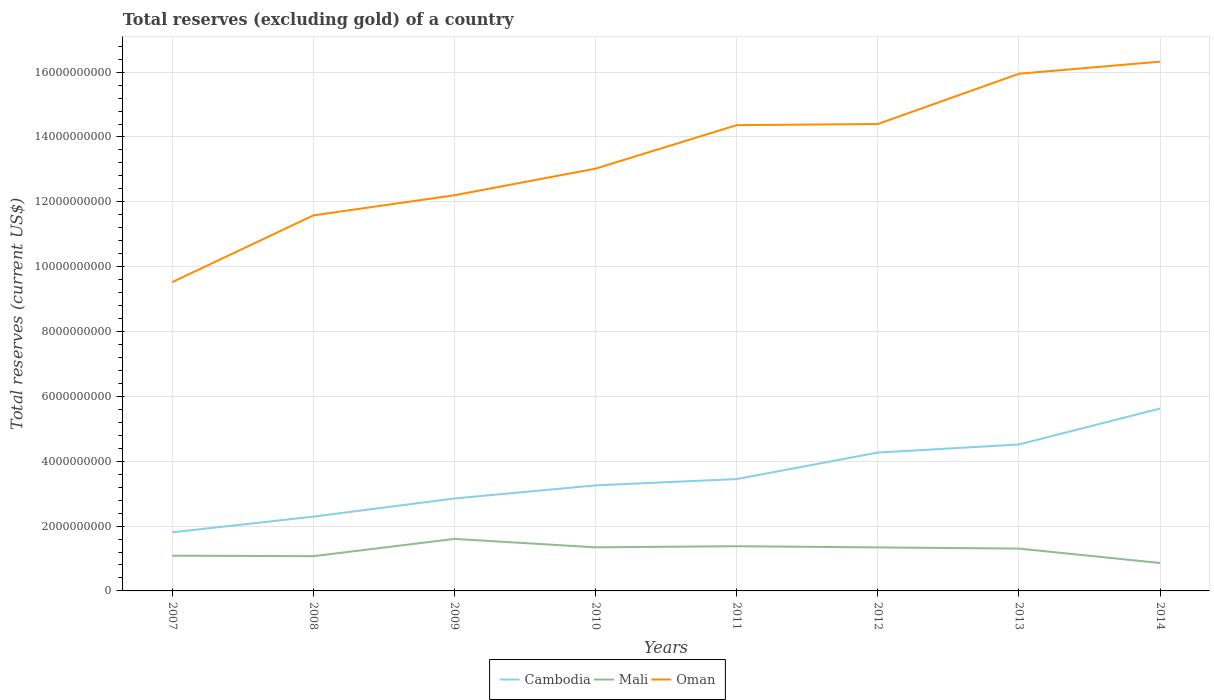Does the line corresponding to Oman intersect with the line corresponding to Cambodia?
Make the answer very short. No. Across all years, what is the maximum total reserves (excluding gold) in Cambodia?
Keep it short and to the point. 1.81e+09. What is the total total reserves (excluding gold) in Mali in the graph?
Give a very brief answer. 7.44e+08. What is the difference between the highest and the second highest total reserves (excluding gold) in Mali?
Your answer should be very brief. 7.44e+08. Is the total reserves (excluding gold) in Mali strictly greater than the total reserves (excluding gold) in Oman over the years?
Make the answer very short. Yes. How many lines are there?
Provide a succinct answer. 3. Does the graph contain grids?
Your answer should be very brief. Yes. Where does the legend appear in the graph?
Provide a succinct answer. Bottom center. How many legend labels are there?
Make the answer very short. 3. What is the title of the graph?
Keep it short and to the point. Total reserves (excluding gold) of a country. What is the label or title of the Y-axis?
Your answer should be very brief. Total reserves (current US$). What is the Total reserves (current US$) of Cambodia in 2007?
Offer a very short reply. 1.81e+09. What is the Total reserves (current US$) of Mali in 2007?
Offer a very short reply. 1.09e+09. What is the Total reserves (current US$) in Oman in 2007?
Give a very brief answer. 9.52e+09. What is the Total reserves (current US$) of Cambodia in 2008?
Provide a succinct answer. 2.29e+09. What is the Total reserves (current US$) of Mali in 2008?
Provide a succinct answer. 1.07e+09. What is the Total reserves (current US$) in Oman in 2008?
Keep it short and to the point. 1.16e+1. What is the Total reserves (current US$) in Cambodia in 2009?
Provide a succinct answer. 2.85e+09. What is the Total reserves (current US$) of Mali in 2009?
Provide a succinct answer. 1.60e+09. What is the Total reserves (current US$) of Oman in 2009?
Make the answer very short. 1.22e+1. What is the Total reserves (current US$) of Cambodia in 2010?
Ensure brevity in your answer.  3.26e+09. What is the Total reserves (current US$) of Mali in 2010?
Provide a succinct answer. 1.34e+09. What is the Total reserves (current US$) of Oman in 2010?
Keep it short and to the point. 1.30e+1. What is the Total reserves (current US$) of Cambodia in 2011?
Your answer should be very brief. 3.45e+09. What is the Total reserves (current US$) of Mali in 2011?
Offer a very short reply. 1.38e+09. What is the Total reserves (current US$) in Oman in 2011?
Provide a succinct answer. 1.44e+1. What is the Total reserves (current US$) in Cambodia in 2012?
Your response must be concise. 4.27e+09. What is the Total reserves (current US$) of Mali in 2012?
Provide a short and direct response. 1.34e+09. What is the Total reserves (current US$) of Oman in 2012?
Offer a terse response. 1.44e+1. What is the Total reserves (current US$) of Cambodia in 2013?
Provide a short and direct response. 4.52e+09. What is the Total reserves (current US$) in Mali in 2013?
Provide a short and direct response. 1.31e+09. What is the Total reserves (current US$) of Oman in 2013?
Offer a very short reply. 1.60e+1. What is the Total reserves (current US$) in Cambodia in 2014?
Provide a short and direct response. 5.63e+09. What is the Total reserves (current US$) of Mali in 2014?
Offer a terse response. 8.61e+08. What is the Total reserves (current US$) of Oman in 2014?
Provide a succinct answer. 1.63e+1. Across all years, what is the maximum Total reserves (current US$) in Cambodia?
Provide a succinct answer. 5.63e+09. Across all years, what is the maximum Total reserves (current US$) in Mali?
Your answer should be very brief. 1.60e+09. Across all years, what is the maximum Total reserves (current US$) in Oman?
Your response must be concise. 1.63e+1. Across all years, what is the minimum Total reserves (current US$) in Cambodia?
Offer a terse response. 1.81e+09. Across all years, what is the minimum Total reserves (current US$) of Mali?
Your response must be concise. 8.61e+08. Across all years, what is the minimum Total reserves (current US$) in Oman?
Make the answer very short. 9.52e+09. What is the total Total reserves (current US$) of Cambodia in the graph?
Keep it short and to the point. 2.81e+1. What is the total Total reserves (current US$) in Mali in the graph?
Your response must be concise. 9.99e+09. What is the total Total reserves (current US$) of Oman in the graph?
Offer a terse response. 1.07e+11. What is the difference between the Total reserves (current US$) of Cambodia in 2007 and that in 2008?
Provide a short and direct response. -4.85e+08. What is the difference between the Total reserves (current US$) in Mali in 2007 and that in 2008?
Offer a very short reply. 1.56e+07. What is the difference between the Total reserves (current US$) of Oman in 2007 and that in 2008?
Make the answer very short. -2.06e+09. What is the difference between the Total reserves (current US$) of Cambodia in 2007 and that in 2009?
Provide a succinct answer. -1.04e+09. What is the difference between the Total reserves (current US$) in Mali in 2007 and that in 2009?
Make the answer very short. -5.17e+08. What is the difference between the Total reserves (current US$) of Oman in 2007 and that in 2009?
Your answer should be very brief. -2.68e+09. What is the difference between the Total reserves (current US$) in Cambodia in 2007 and that in 2010?
Ensure brevity in your answer.  -1.45e+09. What is the difference between the Total reserves (current US$) in Mali in 2007 and that in 2010?
Offer a very short reply. -2.57e+08. What is the difference between the Total reserves (current US$) of Oman in 2007 and that in 2010?
Make the answer very short. -3.50e+09. What is the difference between the Total reserves (current US$) in Cambodia in 2007 and that in 2011?
Keep it short and to the point. -1.64e+09. What is the difference between the Total reserves (current US$) of Mali in 2007 and that in 2011?
Ensure brevity in your answer.  -2.91e+08. What is the difference between the Total reserves (current US$) of Oman in 2007 and that in 2011?
Your answer should be compact. -4.84e+09. What is the difference between the Total reserves (current US$) in Cambodia in 2007 and that in 2012?
Make the answer very short. -2.46e+09. What is the difference between the Total reserves (current US$) of Mali in 2007 and that in 2012?
Offer a terse response. -2.54e+08. What is the difference between the Total reserves (current US$) of Oman in 2007 and that in 2012?
Your answer should be compact. -4.88e+09. What is the difference between the Total reserves (current US$) of Cambodia in 2007 and that in 2013?
Provide a succinct answer. -2.71e+09. What is the difference between the Total reserves (current US$) in Mali in 2007 and that in 2013?
Offer a very short reply. -2.19e+08. What is the difference between the Total reserves (current US$) of Oman in 2007 and that in 2013?
Your answer should be compact. -6.43e+09. What is the difference between the Total reserves (current US$) of Cambodia in 2007 and that in 2014?
Provide a short and direct response. -3.82e+09. What is the difference between the Total reserves (current US$) in Mali in 2007 and that in 2014?
Ensure brevity in your answer.  2.26e+08. What is the difference between the Total reserves (current US$) of Oman in 2007 and that in 2014?
Make the answer very short. -6.80e+09. What is the difference between the Total reserves (current US$) in Cambodia in 2008 and that in 2009?
Provide a short and direct response. -5.60e+08. What is the difference between the Total reserves (current US$) in Mali in 2008 and that in 2009?
Make the answer very short. -5.33e+08. What is the difference between the Total reserves (current US$) of Oman in 2008 and that in 2009?
Your response must be concise. -6.21e+08. What is the difference between the Total reserves (current US$) of Cambodia in 2008 and that in 2010?
Make the answer very short. -9.64e+08. What is the difference between the Total reserves (current US$) in Mali in 2008 and that in 2010?
Your answer should be compact. -2.73e+08. What is the difference between the Total reserves (current US$) of Oman in 2008 and that in 2010?
Your answer should be compact. -1.44e+09. What is the difference between the Total reserves (current US$) in Cambodia in 2008 and that in 2011?
Your response must be concise. -1.16e+09. What is the difference between the Total reserves (current US$) in Mali in 2008 and that in 2011?
Make the answer very short. -3.07e+08. What is the difference between the Total reserves (current US$) of Oman in 2008 and that in 2011?
Offer a very short reply. -2.78e+09. What is the difference between the Total reserves (current US$) in Cambodia in 2008 and that in 2012?
Provide a short and direct response. -1.98e+09. What is the difference between the Total reserves (current US$) in Mali in 2008 and that in 2012?
Offer a very short reply. -2.70e+08. What is the difference between the Total reserves (current US$) in Oman in 2008 and that in 2012?
Your answer should be very brief. -2.82e+09. What is the difference between the Total reserves (current US$) in Cambodia in 2008 and that in 2013?
Offer a very short reply. -2.22e+09. What is the difference between the Total reserves (current US$) of Mali in 2008 and that in 2013?
Ensure brevity in your answer.  -2.34e+08. What is the difference between the Total reserves (current US$) in Oman in 2008 and that in 2013?
Your response must be concise. -4.37e+09. What is the difference between the Total reserves (current US$) in Cambodia in 2008 and that in 2014?
Make the answer very short. -3.33e+09. What is the difference between the Total reserves (current US$) in Mali in 2008 and that in 2014?
Provide a short and direct response. 2.11e+08. What is the difference between the Total reserves (current US$) in Oman in 2008 and that in 2014?
Make the answer very short. -4.74e+09. What is the difference between the Total reserves (current US$) of Cambodia in 2009 and that in 2010?
Offer a very short reply. -4.04e+08. What is the difference between the Total reserves (current US$) in Mali in 2009 and that in 2010?
Offer a terse response. 2.60e+08. What is the difference between the Total reserves (current US$) in Oman in 2009 and that in 2010?
Make the answer very short. -8.21e+08. What is the difference between the Total reserves (current US$) of Cambodia in 2009 and that in 2011?
Make the answer very short. -5.99e+08. What is the difference between the Total reserves (current US$) in Mali in 2009 and that in 2011?
Keep it short and to the point. 2.26e+08. What is the difference between the Total reserves (current US$) in Oman in 2009 and that in 2011?
Provide a short and direct response. -2.16e+09. What is the difference between the Total reserves (current US$) in Cambodia in 2009 and that in 2012?
Ensure brevity in your answer.  -1.42e+09. What is the difference between the Total reserves (current US$) of Mali in 2009 and that in 2012?
Your answer should be very brief. 2.63e+08. What is the difference between the Total reserves (current US$) in Oman in 2009 and that in 2012?
Make the answer very short. -2.20e+09. What is the difference between the Total reserves (current US$) in Cambodia in 2009 and that in 2013?
Offer a very short reply. -1.67e+09. What is the difference between the Total reserves (current US$) of Mali in 2009 and that in 2013?
Provide a succinct answer. 2.99e+08. What is the difference between the Total reserves (current US$) of Oman in 2009 and that in 2013?
Your answer should be compact. -3.75e+09. What is the difference between the Total reserves (current US$) in Cambodia in 2009 and that in 2014?
Provide a succinct answer. -2.77e+09. What is the difference between the Total reserves (current US$) of Mali in 2009 and that in 2014?
Keep it short and to the point. 7.44e+08. What is the difference between the Total reserves (current US$) in Oman in 2009 and that in 2014?
Give a very brief answer. -4.12e+09. What is the difference between the Total reserves (current US$) of Cambodia in 2010 and that in 2011?
Your answer should be compact. -1.95e+08. What is the difference between the Total reserves (current US$) in Mali in 2010 and that in 2011?
Provide a short and direct response. -3.42e+07. What is the difference between the Total reserves (current US$) in Oman in 2010 and that in 2011?
Provide a short and direct response. -1.34e+09. What is the difference between the Total reserves (current US$) of Cambodia in 2010 and that in 2012?
Make the answer very short. -1.01e+09. What is the difference between the Total reserves (current US$) in Mali in 2010 and that in 2012?
Keep it short and to the point. 3.01e+06. What is the difference between the Total reserves (current US$) in Oman in 2010 and that in 2012?
Your answer should be compact. -1.38e+09. What is the difference between the Total reserves (current US$) in Cambodia in 2010 and that in 2013?
Provide a succinct answer. -1.26e+09. What is the difference between the Total reserves (current US$) in Mali in 2010 and that in 2013?
Give a very brief answer. 3.87e+07. What is the difference between the Total reserves (current US$) of Oman in 2010 and that in 2013?
Provide a succinct answer. -2.93e+09. What is the difference between the Total reserves (current US$) in Cambodia in 2010 and that in 2014?
Ensure brevity in your answer.  -2.37e+09. What is the difference between the Total reserves (current US$) of Mali in 2010 and that in 2014?
Provide a succinct answer. 4.84e+08. What is the difference between the Total reserves (current US$) in Oman in 2010 and that in 2014?
Your answer should be very brief. -3.30e+09. What is the difference between the Total reserves (current US$) of Cambodia in 2011 and that in 2012?
Ensure brevity in your answer.  -8.18e+08. What is the difference between the Total reserves (current US$) in Mali in 2011 and that in 2012?
Keep it short and to the point. 3.72e+07. What is the difference between the Total reserves (current US$) of Oman in 2011 and that in 2012?
Ensure brevity in your answer.  -3.48e+07. What is the difference between the Total reserves (current US$) of Cambodia in 2011 and that in 2013?
Ensure brevity in your answer.  -1.07e+09. What is the difference between the Total reserves (current US$) of Mali in 2011 and that in 2013?
Keep it short and to the point. 7.29e+07. What is the difference between the Total reserves (current US$) of Oman in 2011 and that in 2013?
Make the answer very short. -1.59e+09. What is the difference between the Total reserves (current US$) in Cambodia in 2011 and that in 2014?
Offer a very short reply. -2.18e+09. What is the difference between the Total reserves (current US$) in Mali in 2011 and that in 2014?
Give a very brief answer. 5.18e+08. What is the difference between the Total reserves (current US$) in Oman in 2011 and that in 2014?
Ensure brevity in your answer.  -1.96e+09. What is the difference between the Total reserves (current US$) in Cambodia in 2012 and that in 2013?
Ensure brevity in your answer.  -2.49e+08. What is the difference between the Total reserves (current US$) of Mali in 2012 and that in 2013?
Offer a terse response. 3.57e+07. What is the difference between the Total reserves (current US$) in Oman in 2012 and that in 2013?
Offer a terse response. -1.55e+09. What is the difference between the Total reserves (current US$) of Cambodia in 2012 and that in 2014?
Offer a very short reply. -1.36e+09. What is the difference between the Total reserves (current US$) of Mali in 2012 and that in 2014?
Provide a succinct answer. 4.81e+08. What is the difference between the Total reserves (current US$) in Oman in 2012 and that in 2014?
Keep it short and to the point. -1.92e+09. What is the difference between the Total reserves (current US$) of Cambodia in 2013 and that in 2014?
Make the answer very short. -1.11e+09. What is the difference between the Total reserves (current US$) in Mali in 2013 and that in 2014?
Your answer should be compact. 4.45e+08. What is the difference between the Total reserves (current US$) of Oman in 2013 and that in 2014?
Keep it short and to the point. -3.73e+08. What is the difference between the Total reserves (current US$) in Cambodia in 2007 and the Total reserves (current US$) in Mali in 2008?
Your answer should be very brief. 7.35e+08. What is the difference between the Total reserves (current US$) of Cambodia in 2007 and the Total reserves (current US$) of Oman in 2008?
Ensure brevity in your answer.  -9.77e+09. What is the difference between the Total reserves (current US$) in Mali in 2007 and the Total reserves (current US$) in Oman in 2008?
Your answer should be compact. -1.05e+1. What is the difference between the Total reserves (current US$) of Cambodia in 2007 and the Total reserves (current US$) of Mali in 2009?
Provide a short and direct response. 2.02e+08. What is the difference between the Total reserves (current US$) of Cambodia in 2007 and the Total reserves (current US$) of Oman in 2009?
Make the answer very short. -1.04e+1. What is the difference between the Total reserves (current US$) in Mali in 2007 and the Total reserves (current US$) in Oman in 2009?
Offer a terse response. -1.11e+1. What is the difference between the Total reserves (current US$) of Cambodia in 2007 and the Total reserves (current US$) of Mali in 2010?
Make the answer very short. 4.63e+08. What is the difference between the Total reserves (current US$) in Cambodia in 2007 and the Total reserves (current US$) in Oman in 2010?
Your response must be concise. -1.12e+1. What is the difference between the Total reserves (current US$) of Mali in 2007 and the Total reserves (current US$) of Oman in 2010?
Offer a very short reply. -1.19e+1. What is the difference between the Total reserves (current US$) of Cambodia in 2007 and the Total reserves (current US$) of Mali in 2011?
Ensure brevity in your answer.  4.28e+08. What is the difference between the Total reserves (current US$) of Cambodia in 2007 and the Total reserves (current US$) of Oman in 2011?
Ensure brevity in your answer.  -1.26e+1. What is the difference between the Total reserves (current US$) in Mali in 2007 and the Total reserves (current US$) in Oman in 2011?
Offer a very short reply. -1.33e+1. What is the difference between the Total reserves (current US$) of Cambodia in 2007 and the Total reserves (current US$) of Mali in 2012?
Give a very brief answer. 4.66e+08. What is the difference between the Total reserves (current US$) in Cambodia in 2007 and the Total reserves (current US$) in Oman in 2012?
Offer a terse response. -1.26e+1. What is the difference between the Total reserves (current US$) of Mali in 2007 and the Total reserves (current US$) of Oman in 2012?
Your answer should be compact. -1.33e+1. What is the difference between the Total reserves (current US$) in Cambodia in 2007 and the Total reserves (current US$) in Mali in 2013?
Provide a short and direct response. 5.01e+08. What is the difference between the Total reserves (current US$) in Cambodia in 2007 and the Total reserves (current US$) in Oman in 2013?
Give a very brief answer. -1.41e+1. What is the difference between the Total reserves (current US$) of Mali in 2007 and the Total reserves (current US$) of Oman in 2013?
Ensure brevity in your answer.  -1.49e+1. What is the difference between the Total reserves (current US$) in Cambodia in 2007 and the Total reserves (current US$) in Mali in 2014?
Offer a very short reply. 9.46e+08. What is the difference between the Total reserves (current US$) of Cambodia in 2007 and the Total reserves (current US$) of Oman in 2014?
Keep it short and to the point. -1.45e+1. What is the difference between the Total reserves (current US$) in Mali in 2007 and the Total reserves (current US$) in Oman in 2014?
Give a very brief answer. -1.52e+1. What is the difference between the Total reserves (current US$) in Cambodia in 2008 and the Total reserves (current US$) in Mali in 2009?
Give a very brief answer. 6.87e+08. What is the difference between the Total reserves (current US$) of Cambodia in 2008 and the Total reserves (current US$) of Oman in 2009?
Your answer should be compact. -9.91e+09. What is the difference between the Total reserves (current US$) in Mali in 2008 and the Total reserves (current US$) in Oman in 2009?
Ensure brevity in your answer.  -1.11e+1. What is the difference between the Total reserves (current US$) of Cambodia in 2008 and the Total reserves (current US$) of Mali in 2010?
Give a very brief answer. 9.47e+08. What is the difference between the Total reserves (current US$) of Cambodia in 2008 and the Total reserves (current US$) of Oman in 2010?
Give a very brief answer. -1.07e+1. What is the difference between the Total reserves (current US$) of Mali in 2008 and the Total reserves (current US$) of Oman in 2010?
Offer a very short reply. -1.20e+1. What is the difference between the Total reserves (current US$) in Cambodia in 2008 and the Total reserves (current US$) in Mali in 2011?
Offer a very short reply. 9.13e+08. What is the difference between the Total reserves (current US$) of Cambodia in 2008 and the Total reserves (current US$) of Oman in 2011?
Give a very brief answer. -1.21e+1. What is the difference between the Total reserves (current US$) of Mali in 2008 and the Total reserves (current US$) of Oman in 2011?
Offer a very short reply. -1.33e+1. What is the difference between the Total reserves (current US$) in Cambodia in 2008 and the Total reserves (current US$) in Mali in 2012?
Offer a very short reply. 9.50e+08. What is the difference between the Total reserves (current US$) in Cambodia in 2008 and the Total reserves (current US$) in Oman in 2012?
Your answer should be compact. -1.21e+1. What is the difference between the Total reserves (current US$) of Mali in 2008 and the Total reserves (current US$) of Oman in 2012?
Your answer should be very brief. -1.33e+1. What is the difference between the Total reserves (current US$) in Cambodia in 2008 and the Total reserves (current US$) in Mali in 2013?
Offer a terse response. 9.86e+08. What is the difference between the Total reserves (current US$) of Cambodia in 2008 and the Total reserves (current US$) of Oman in 2013?
Ensure brevity in your answer.  -1.37e+1. What is the difference between the Total reserves (current US$) in Mali in 2008 and the Total reserves (current US$) in Oman in 2013?
Your answer should be very brief. -1.49e+1. What is the difference between the Total reserves (current US$) of Cambodia in 2008 and the Total reserves (current US$) of Mali in 2014?
Make the answer very short. 1.43e+09. What is the difference between the Total reserves (current US$) in Cambodia in 2008 and the Total reserves (current US$) in Oman in 2014?
Ensure brevity in your answer.  -1.40e+1. What is the difference between the Total reserves (current US$) of Mali in 2008 and the Total reserves (current US$) of Oman in 2014?
Keep it short and to the point. -1.53e+1. What is the difference between the Total reserves (current US$) of Cambodia in 2009 and the Total reserves (current US$) of Mali in 2010?
Keep it short and to the point. 1.51e+09. What is the difference between the Total reserves (current US$) of Cambodia in 2009 and the Total reserves (current US$) of Oman in 2010?
Provide a short and direct response. -1.02e+1. What is the difference between the Total reserves (current US$) of Mali in 2009 and the Total reserves (current US$) of Oman in 2010?
Your answer should be compact. -1.14e+1. What is the difference between the Total reserves (current US$) of Cambodia in 2009 and the Total reserves (current US$) of Mali in 2011?
Keep it short and to the point. 1.47e+09. What is the difference between the Total reserves (current US$) in Cambodia in 2009 and the Total reserves (current US$) in Oman in 2011?
Provide a succinct answer. -1.15e+1. What is the difference between the Total reserves (current US$) of Mali in 2009 and the Total reserves (current US$) of Oman in 2011?
Ensure brevity in your answer.  -1.28e+1. What is the difference between the Total reserves (current US$) of Cambodia in 2009 and the Total reserves (current US$) of Mali in 2012?
Keep it short and to the point. 1.51e+09. What is the difference between the Total reserves (current US$) in Cambodia in 2009 and the Total reserves (current US$) in Oman in 2012?
Your response must be concise. -1.15e+1. What is the difference between the Total reserves (current US$) in Mali in 2009 and the Total reserves (current US$) in Oman in 2012?
Provide a succinct answer. -1.28e+1. What is the difference between the Total reserves (current US$) in Cambodia in 2009 and the Total reserves (current US$) in Mali in 2013?
Your answer should be very brief. 1.55e+09. What is the difference between the Total reserves (current US$) of Cambodia in 2009 and the Total reserves (current US$) of Oman in 2013?
Ensure brevity in your answer.  -1.31e+1. What is the difference between the Total reserves (current US$) in Mali in 2009 and the Total reserves (current US$) in Oman in 2013?
Provide a short and direct response. -1.43e+1. What is the difference between the Total reserves (current US$) of Cambodia in 2009 and the Total reserves (current US$) of Mali in 2014?
Make the answer very short. 1.99e+09. What is the difference between the Total reserves (current US$) of Cambodia in 2009 and the Total reserves (current US$) of Oman in 2014?
Your answer should be compact. -1.35e+1. What is the difference between the Total reserves (current US$) of Mali in 2009 and the Total reserves (current US$) of Oman in 2014?
Give a very brief answer. -1.47e+1. What is the difference between the Total reserves (current US$) of Cambodia in 2010 and the Total reserves (current US$) of Mali in 2011?
Provide a short and direct response. 1.88e+09. What is the difference between the Total reserves (current US$) in Cambodia in 2010 and the Total reserves (current US$) in Oman in 2011?
Offer a very short reply. -1.11e+1. What is the difference between the Total reserves (current US$) in Mali in 2010 and the Total reserves (current US$) in Oman in 2011?
Give a very brief answer. -1.30e+1. What is the difference between the Total reserves (current US$) in Cambodia in 2010 and the Total reserves (current US$) in Mali in 2012?
Provide a short and direct response. 1.91e+09. What is the difference between the Total reserves (current US$) of Cambodia in 2010 and the Total reserves (current US$) of Oman in 2012?
Ensure brevity in your answer.  -1.11e+1. What is the difference between the Total reserves (current US$) in Mali in 2010 and the Total reserves (current US$) in Oman in 2012?
Offer a very short reply. -1.31e+1. What is the difference between the Total reserves (current US$) of Cambodia in 2010 and the Total reserves (current US$) of Mali in 2013?
Keep it short and to the point. 1.95e+09. What is the difference between the Total reserves (current US$) in Cambodia in 2010 and the Total reserves (current US$) in Oman in 2013?
Provide a succinct answer. -1.27e+1. What is the difference between the Total reserves (current US$) in Mali in 2010 and the Total reserves (current US$) in Oman in 2013?
Give a very brief answer. -1.46e+1. What is the difference between the Total reserves (current US$) of Cambodia in 2010 and the Total reserves (current US$) of Mali in 2014?
Make the answer very short. 2.39e+09. What is the difference between the Total reserves (current US$) in Cambodia in 2010 and the Total reserves (current US$) in Oman in 2014?
Your response must be concise. -1.31e+1. What is the difference between the Total reserves (current US$) in Mali in 2010 and the Total reserves (current US$) in Oman in 2014?
Offer a terse response. -1.50e+1. What is the difference between the Total reserves (current US$) of Cambodia in 2011 and the Total reserves (current US$) of Mali in 2012?
Offer a terse response. 2.11e+09. What is the difference between the Total reserves (current US$) of Cambodia in 2011 and the Total reserves (current US$) of Oman in 2012?
Your response must be concise. -1.10e+1. What is the difference between the Total reserves (current US$) in Mali in 2011 and the Total reserves (current US$) in Oman in 2012?
Offer a very short reply. -1.30e+1. What is the difference between the Total reserves (current US$) in Cambodia in 2011 and the Total reserves (current US$) in Mali in 2013?
Your response must be concise. 2.14e+09. What is the difference between the Total reserves (current US$) in Cambodia in 2011 and the Total reserves (current US$) in Oman in 2013?
Offer a terse response. -1.25e+1. What is the difference between the Total reserves (current US$) in Mali in 2011 and the Total reserves (current US$) in Oman in 2013?
Keep it short and to the point. -1.46e+1. What is the difference between the Total reserves (current US$) in Cambodia in 2011 and the Total reserves (current US$) in Mali in 2014?
Ensure brevity in your answer.  2.59e+09. What is the difference between the Total reserves (current US$) in Cambodia in 2011 and the Total reserves (current US$) in Oman in 2014?
Provide a short and direct response. -1.29e+1. What is the difference between the Total reserves (current US$) in Mali in 2011 and the Total reserves (current US$) in Oman in 2014?
Offer a very short reply. -1.49e+1. What is the difference between the Total reserves (current US$) of Cambodia in 2012 and the Total reserves (current US$) of Mali in 2013?
Offer a terse response. 2.96e+09. What is the difference between the Total reserves (current US$) in Cambodia in 2012 and the Total reserves (current US$) in Oman in 2013?
Offer a terse response. -1.17e+1. What is the difference between the Total reserves (current US$) of Mali in 2012 and the Total reserves (current US$) of Oman in 2013?
Make the answer very short. -1.46e+1. What is the difference between the Total reserves (current US$) of Cambodia in 2012 and the Total reserves (current US$) of Mali in 2014?
Offer a very short reply. 3.41e+09. What is the difference between the Total reserves (current US$) in Cambodia in 2012 and the Total reserves (current US$) in Oman in 2014?
Offer a terse response. -1.21e+1. What is the difference between the Total reserves (current US$) of Mali in 2012 and the Total reserves (current US$) of Oman in 2014?
Offer a terse response. -1.50e+1. What is the difference between the Total reserves (current US$) of Cambodia in 2013 and the Total reserves (current US$) of Mali in 2014?
Offer a very short reply. 3.66e+09. What is the difference between the Total reserves (current US$) of Cambodia in 2013 and the Total reserves (current US$) of Oman in 2014?
Provide a short and direct response. -1.18e+1. What is the difference between the Total reserves (current US$) in Mali in 2013 and the Total reserves (current US$) in Oman in 2014?
Make the answer very short. -1.50e+1. What is the average Total reserves (current US$) in Cambodia per year?
Ensure brevity in your answer.  3.51e+09. What is the average Total reserves (current US$) of Mali per year?
Your answer should be very brief. 1.25e+09. What is the average Total reserves (current US$) of Oman per year?
Keep it short and to the point. 1.34e+1. In the year 2007, what is the difference between the Total reserves (current US$) in Cambodia and Total reserves (current US$) in Mali?
Make the answer very short. 7.20e+08. In the year 2007, what is the difference between the Total reserves (current US$) in Cambodia and Total reserves (current US$) in Oman?
Your answer should be compact. -7.72e+09. In the year 2007, what is the difference between the Total reserves (current US$) of Mali and Total reserves (current US$) of Oman?
Offer a terse response. -8.44e+09. In the year 2008, what is the difference between the Total reserves (current US$) of Cambodia and Total reserves (current US$) of Mali?
Provide a succinct answer. 1.22e+09. In the year 2008, what is the difference between the Total reserves (current US$) in Cambodia and Total reserves (current US$) in Oman?
Ensure brevity in your answer.  -9.29e+09. In the year 2008, what is the difference between the Total reserves (current US$) of Mali and Total reserves (current US$) of Oman?
Provide a succinct answer. -1.05e+1. In the year 2009, what is the difference between the Total reserves (current US$) of Cambodia and Total reserves (current US$) of Mali?
Offer a very short reply. 1.25e+09. In the year 2009, what is the difference between the Total reserves (current US$) of Cambodia and Total reserves (current US$) of Oman?
Offer a very short reply. -9.35e+09. In the year 2009, what is the difference between the Total reserves (current US$) in Mali and Total reserves (current US$) in Oman?
Offer a very short reply. -1.06e+1. In the year 2010, what is the difference between the Total reserves (current US$) of Cambodia and Total reserves (current US$) of Mali?
Your answer should be compact. 1.91e+09. In the year 2010, what is the difference between the Total reserves (current US$) in Cambodia and Total reserves (current US$) in Oman?
Ensure brevity in your answer.  -9.77e+09. In the year 2010, what is the difference between the Total reserves (current US$) of Mali and Total reserves (current US$) of Oman?
Make the answer very short. -1.17e+1. In the year 2011, what is the difference between the Total reserves (current US$) in Cambodia and Total reserves (current US$) in Mali?
Ensure brevity in your answer.  2.07e+09. In the year 2011, what is the difference between the Total reserves (current US$) in Cambodia and Total reserves (current US$) in Oman?
Your answer should be very brief. -1.09e+1. In the year 2011, what is the difference between the Total reserves (current US$) in Mali and Total reserves (current US$) in Oman?
Provide a short and direct response. -1.30e+1. In the year 2012, what is the difference between the Total reserves (current US$) in Cambodia and Total reserves (current US$) in Mali?
Your answer should be compact. 2.93e+09. In the year 2012, what is the difference between the Total reserves (current US$) in Cambodia and Total reserves (current US$) in Oman?
Your answer should be compact. -1.01e+1. In the year 2012, what is the difference between the Total reserves (current US$) of Mali and Total reserves (current US$) of Oman?
Provide a succinct answer. -1.31e+1. In the year 2013, what is the difference between the Total reserves (current US$) of Cambodia and Total reserves (current US$) of Mali?
Offer a very short reply. 3.21e+09. In the year 2013, what is the difference between the Total reserves (current US$) of Cambodia and Total reserves (current US$) of Oman?
Your answer should be compact. -1.14e+1. In the year 2013, what is the difference between the Total reserves (current US$) in Mali and Total reserves (current US$) in Oman?
Provide a succinct answer. -1.46e+1. In the year 2014, what is the difference between the Total reserves (current US$) in Cambodia and Total reserves (current US$) in Mali?
Make the answer very short. 4.77e+09. In the year 2014, what is the difference between the Total reserves (current US$) in Cambodia and Total reserves (current US$) in Oman?
Your answer should be compact. -1.07e+1. In the year 2014, what is the difference between the Total reserves (current US$) of Mali and Total reserves (current US$) of Oman?
Keep it short and to the point. -1.55e+1. What is the ratio of the Total reserves (current US$) of Cambodia in 2007 to that in 2008?
Your response must be concise. 0.79. What is the ratio of the Total reserves (current US$) in Mali in 2007 to that in 2008?
Your answer should be very brief. 1.01. What is the ratio of the Total reserves (current US$) of Oman in 2007 to that in 2008?
Keep it short and to the point. 0.82. What is the ratio of the Total reserves (current US$) in Cambodia in 2007 to that in 2009?
Provide a short and direct response. 0.63. What is the ratio of the Total reserves (current US$) of Mali in 2007 to that in 2009?
Your response must be concise. 0.68. What is the ratio of the Total reserves (current US$) in Oman in 2007 to that in 2009?
Your answer should be very brief. 0.78. What is the ratio of the Total reserves (current US$) of Cambodia in 2007 to that in 2010?
Offer a terse response. 0.56. What is the ratio of the Total reserves (current US$) of Mali in 2007 to that in 2010?
Provide a succinct answer. 0.81. What is the ratio of the Total reserves (current US$) of Oman in 2007 to that in 2010?
Give a very brief answer. 0.73. What is the ratio of the Total reserves (current US$) of Cambodia in 2007 to that in 2011?
Provide a succinct answer. 0.52. What is the ratio of the Total reserves (current US$) of Mali in 2007 to that in 2011?
Ensure brevity in your answer.  0.79. What is the ratio of the Total reserves (current US$) in Oman in 2007 to that in 2011?
Provide a short and direct response. 0.66. What is the ratio of the Total reserves (current US$) of Cambodia in 2007 to that in 2012?
Your answer should be very brief. 0.42. What is the ratio of the Total reserves (current US$) in Mali in 2007 to that in 2012?
Provide a succinct answer. 0.81. What is the ratio of the Total reserves (current US$) in Oman in 2007 to that in 2012?
Ensure brevity in your answer.  0.66. What is the ratio of the Total reserves (current US$) in Cambodia in 2007 to that in 2013?
Offer a very short reply. 0.4. What is the ratio of the Total reserves (current US$) of Mali in 2007 to that in 2013?
Offer a terse response. 0.83. What is the ratio of the Total reserves (current US$) of Oman in 2007 to that in 2013?
Offer a terse response. 0.6. What is the ratio of the Total reserves (current US$) of Cambodia in 2007 to that in 2014?
Provide a succinct answer. 0.32. What is the ratio of the Total reserves (current US$) of Mali in 2007 to that in 2014?
Keep it short and to the point. 1.26. What is the ratio of the Total reserves (current US$) of Oman in 2007 to that in 2014?
Offer a terse response. 0.58. What is the ratio of the Total reserves (current US$) in Cambodia in 2008 to that in 2009?
Provide a succinct answer. 0.8. What is the ratio of the Total reserves (current US$) in Mali in 2008 to that in 2009?
Your response must be concise. 0.67. What is the ratio of the Total reserves (current US$) in Oman in 2008 to that in 2009?
Make the answer very short. 0.95. What is the ratio of the Total reserves (current US$) of Cambodia in 2008 to that in 2010?
Provide a short and direct response. 0.7. What is the ratio of the Total reserves (current US$) of Mali in 2008 to that in 2010?
Make the answer very short. 0.8. What is the ratio of the Total reserves (current US$) in Oman in 2008 to that in 2010?
Offer a terse response. 0.89. What is the ratio of the Total reserves (current US$) in Cambodia in 2008 to that in 2011?
Offer a terse response. 0.66. What is the ratio of the Total reserves (current US$) in Mali in 2008 to that in 2011?
Offer a very short reply. 0.78. What is the ratio of the Total reserves (current US$) of Oman in 2008 to that in 2011?
Your response must be concise. 0.81. What is the ratio of the Total reserves (current US$) in Cambodia in 2008 to that in 2012?
Offer a terse response. 0.54. What is the ratio of the Total reserves (current US$) in Mali in 2008 to that in 2012?
Provide a succinct answer. 0.8. What is the ratio of the Total reserves (current US$) in Oman in 2008 to that in 2012?
Ensure brevity in your answer.  0.8. What is the ratio of the Total reserves (current US$) of Cambodia in 2008 to that in 2013?
Offer a terse response. 0.51. What is the ratio of the Total reserves (current US$) of Mali in 2008 to that in 2013?
Your answer should be very brief. 0.82. What is the ratio of the Total reserves (current US$) in Oman in 2008 to that in 2013?
Offer a very short reply. 0.73. What is the ratio of the Total reserves (current US$) of Cambodia in 2008 to that in 2014?
Give a very brief answer. 0.41. What is the ratio of the Total reserves (current US$) of Mali in 2008 to that in 2014?
Offer a terse response. 1.24. What is the ratio of the Total reserves (current US$) in Oman in 2008 to that in 2014?
Provide a short and direct response. 0.71. What is the ratio of the Total reserves (current US$) of Cambodia in 2009 to that in 2010?
Give a very brief answer. 0.88. What is the ratio of the Total reserves (current US$) in Mali in 2009 to that in 2010?
Provide a succinct answer. 1.19. What is the ratio of the Total reserves (current US$) in Oman in 2009 to that in 2010?
Ensure brevity in your answer.  0.94. What is the ratio of the Total reserves (current US$) of Cambodia in 2009 to that in 2011?
Offer a very short reply. 0.83. What is the ratio of the Total reserves (current US$) of Mali in 2009 to that in 2011?
Your answer should be compact. 1.16. What is the ratio of the Total reserves (current US$) of Oman in 2009 to that in 2011?
Keep it short and to the point. 0.85. What is the ratio of the Total reserves (current US$) in Cambodia in 2009 to that in 2012?
Your answer should be compact. 0.67. What is the ratio of the Total reserves (current US$) of Mali in 2009 to that in 2012?
Your response must be concise. 1.2. What is the ratio of the Total reserves (current US$) in Oman in 2009 to that in 2012?
Your response must be concise. 0.85. What is the ratio of the Total reserves (current US$) of Cambodia in 2009 to that in 2013?
Make the answer very short. 0.63. What is the ratio of the Total reserves (current US$) of Mali in 2009 to that in 2013?
Give a very brief answer. 1.23. What is the ratio of the Total reserves (current US$) in Oman in 2009 to that in 2013?
Provide a short and direct response. 0.77. What is the ratio of the Total reserves (current US$) of Cambodia in 2009 to that in 2014?
Ensure brevity in your answer.  0.51. What is the ratio of the Total reserves (current US$) in Mali in 2009 to that in 2014?
Your answer should be compact. 1.86. What is the ratio of the Total reserves (current US$) of Oman in 2009 to that in 2014?
Your answer should be compact. 0.75. What is the ratio of the Total reserves (current US$) in Cambodia in 2010 to that in 2011?
Ensure brevity in your answer.  0.94. What is the ratio of the Total reserves (current US$) of Mali in 2010 to that in 2011?
Provide a succinct answer. 0.98. What is the ratio of the Total reserves (current US$) of Oman in 2010 to that in 2011?
Offer a very short reply. 0.91. What is the ratio of the Total reserves (current US$) in Cambodia in 2010 to that in 2012?
Ensure brevity in your answer.  0.76. What is the ratio of the Total reserves (current US$) in Oman in 2010 to that in 2012?
Ensure brevity in your answer.  0.9. What is the ratio of the Total reserves (current US$) in Cambodia in 2010 to that in 2013?
Offer a terse response. 0.72. What is the ratio of the Total reserves (current US$) of Mali in 2010 to that in 2013?
Ensure brevity in your answer.  1.03. What is the ratio of the Total reserves (current US$) in Oman in 2010 to that in 2013?
Offer a very short reply. 0.82. What is the ratio of the Total reserves (current US$) of Cambodia in 2010 to that in 2014?
Ensure brevity in your answer.  0.58. What is the ratio of the Total reserves (current US$) in Mali in 2010 to that in 2014?
Provide a short and direct response. 1.56. What is the ratio of the Total reserves (current US$) in Oman in 2010 to that in 2014?
Ensure brevity in your answer.  0.8. What is the ratio of the Total reserves (current US$) of Cambodia in 2011 to that in 2012?
Your answer should be compact. 0.81. What is the ratio of the Total reserves (current US$) in Mali in 2011 to that in 2012?
Give a very brief answer. 1.03. What is the ratio of the Total reserves (current US$) of Cambodia in 2011 to that in 2013?
Your answer should be compact. 0.76. What is the ratio of the Total reserves (current US$) of Mali in 2011 to that in 2013?
Make the answer very short. 1.06. What is the ratio of the Total reserves (current US$) of Oman in 2011 to that in 2013?
Give a very brief answer. 0.9. What is the ratio of the Total reserves (current US$) in Cambodia in 2011 to that in 2014?
Your answer should be very brief. 0.61. What is the ratio of the Total reserves (current US$) of Mali in 2011 to that in 2014?
Provide a short and direct response. 1.6. What is the ratio of the Total reserves (current US$) in Oman in 2011 to that in 2014?
Make the answer very short. 0.88. What is the ratio of the Total reserves (current US$) in Cambodia in 2012 to that in 2013?
Your answer should be compact. 0.94. What is the ratio of the Total reserves (current US$) in Mali in 2012 to that in 2013?
Give a very brief answer. 1.03. What is the ratio of the Total reserves (current US$) in Oman in 2012 to that in 2013?
Ensure brevity in your answer.  0.9. What is the ratio of the Total reserves (current US$) of Cambodia in 2012 to that in 2014?
Give a very brief answer. 0.76. What is the ratio of the Total reserves (current US$) of Mali in 2012 to that in 2014?
Your response must be concise. 1.56. What is the ratio of the Total reserves (current US$) in Oman in 2012 to that in 2014?
Offer a terse response. 0.88. What is the ratio of the Total reserves (current US$) in Cambodia in 2013 to that in 2014?
Your response must be concise. 0.8. What is the ratio of the Total reserves (current US$) of Mali in 2013 to that in 2014?
Your response must be concise. 1.52. What is the ratio of the Total reserves (current US$) in Oman in 2013 to that in 2014?
Give a very brief answer. 0.98. What is the difference between the highest and the second highest Total reserves (current US$) in Cambodia?
Offer a terse response. 1.11e+09. What is the difference between the highest and the second highest Total reserves (current US$) in Mali?
Make the answer very short. 2.26e+08. What is the difference between the highest and the second highest Total reserves (current US$) in Oman?
Your answer should be compact. 3.73e+08. What is the difference between the highest and the lowest Total reserves (current US$) of Cambodia?
Ensure brevity in your answer.  3.82e+09. What is the difference between the highest and the lowest Total reserves (current US$) in Mali?
Provide a short and direct response. 7.44e+08. What is the difference between the highest and the lowest Total reserves (current US$) in Oman?
Your answer should be compact. 6.80e+09. 